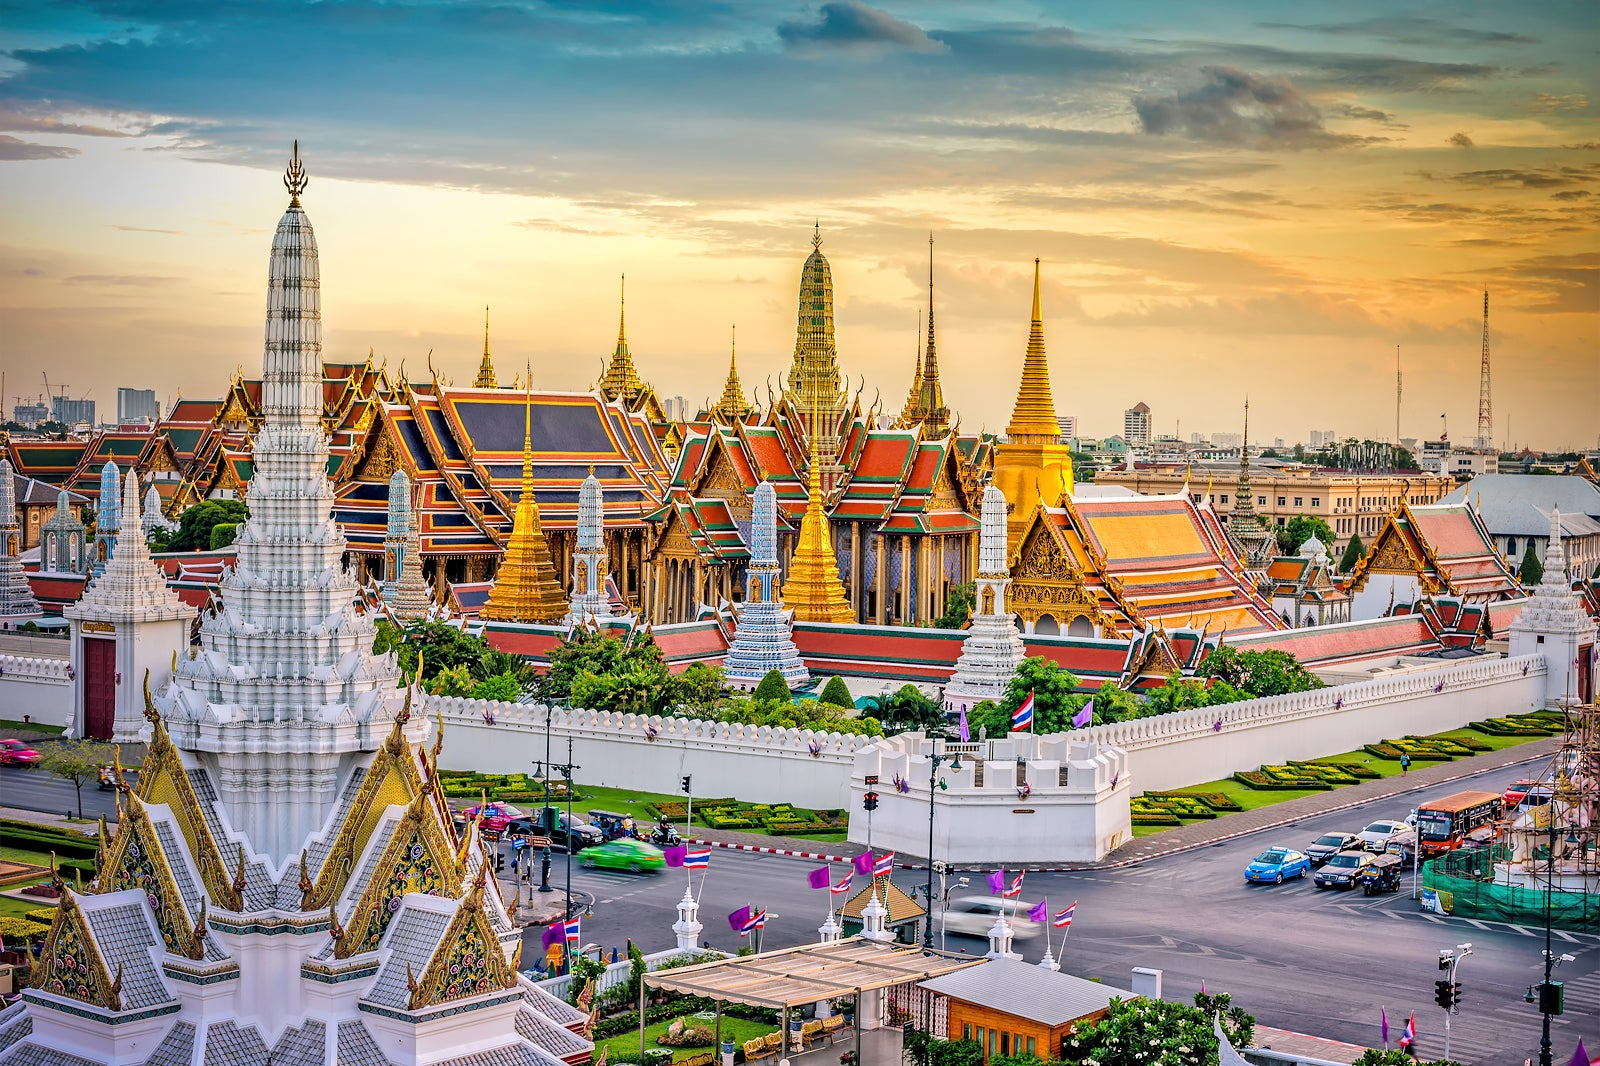Given the grandeur of the Grand Palace, imagine it in a futuristic scenario. Describe the possible changes while maintaining its historical essence. In a futuristic scenario, the Grand Palace would seamlessly blend advanced technological innovations with its historical essence. The traditional red and gold roofs could be embedded with solar panels designed to be nearly invisible, maintaining the original aesthetic while harnessing renewable energy. The walls and pagodas might be fitted with smart lighting that highlights the intricate designs in various ambient hues during the evening. Holographic guides could provide visitors with interactive historical tours, bringing ancient stories and royal ceremonies to life in vivid detail. Advanced preservation techniques, including climate control and structural sensors, would ensure the palace’s longevity without compromising its traditional architecture. The fusion of past and future would create a mesmerizing vision of continuity and progress. 